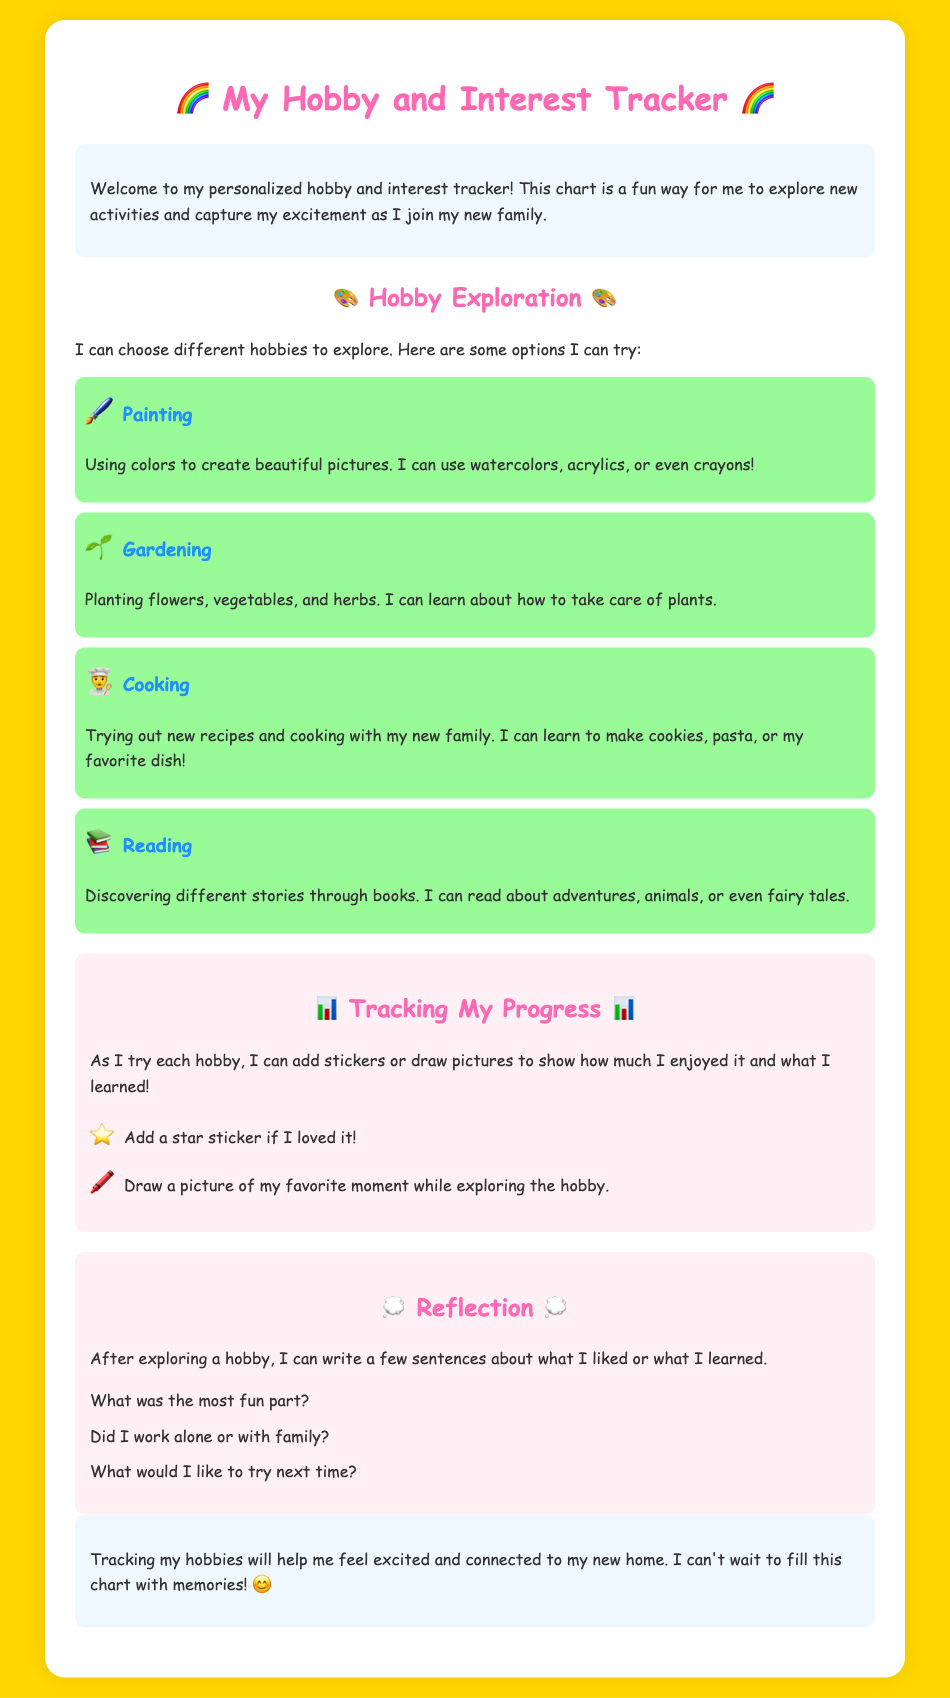What is the title of the document? The title of the document is the main heading found at the top of the page.
Answer: My Hobby and Interest Tracker What is the background color of the page? The background color is specified in the style section of the document.
Answer: Gold What hobby involves using colors? The hobby that involves using colors is listed in the section about exploring hobbies.
Answer: Painting What can I add to show my feelings about a hobby? The document mentions ways to express enjoyment for hobbies in the tracking section.
Answer: Stickers or drawings What type of questions can I write after exploring a hobby? The reflection section provides prompts to think about after trying a hobby.
Answer: Sentences about my experience How many hobbies are listed in the document? The number of hobbies can be counted from the sections detailing each hobby.
Answer: Four What emoji represents Cooking? The emoji associated with Cooking can be found next to the hobby description in the document.
Answer: 👨‍🍳 What color is the reflection section? The background color of each section is described in the styling of the document.
Answer: Light pink 